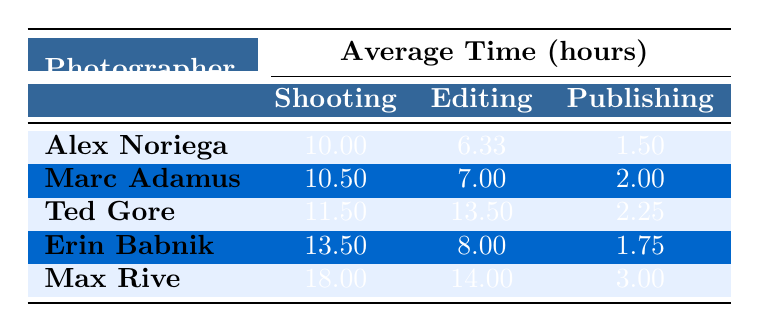What is the average shooting time for Ted Gore? The table shows that Ted Gore has two entries. The shooting times are 9 hours and 14 hours. To find the average, we calculate (9 + 14) / 2 = 23 / 2 = 11.5 hours.
Answer: 11.5 hours Which photographer spent the most time on editing? Looking at the editing times, Ted Gore has the highest time of 13.5 hours. We compare the editing times of all photographers, and Ted Gore's editing time is greater than the others.
Answer: Ted Gore Is the average publishing time for Erin Babnik greater than 2 hours? The table shows that Erin Babnik has an average publishing time of 1.75 hours. Since 1.75 is less than 2, we conclude that her average publishing time is not greater than 2 hours.
Answer: No What is the total time spent on all three phases by Max Rive? Max Rive's times are 18 hours for shooting, 14 hours for editing, and 3 hours for publishing. To find the total, we add these amounts together: 18 + 14 + 3 = 35 hours.
Answer: 35 hours Who spent the least amount of time on publishing? Reviewing the publishing times, the lowest is 1 hour, which belongs to both Yosemite and Oregon Coast entries by Alex Noriega and Marc Adamus. Therefore, these photographers spent the least time on publishing.
Answer: Alex Noriega and Marc Adamus What is the average editing time across all photographers? To calculate the average editing time, we sum all editing times: (8 + 6 + 5 + 10 + 4 + 12 + 15 + 7 + 9 + 14) = 90 hours across 10 photographers. Then, we divide 90 by 10 to get an average of 9 hours.
Answer: 9 hours Did Marc Adamus spend more time on shooting than Erin Babnik? Marc Adamus has an average shooting time of 10.5 hours, while Erin Babnik has 13.5 hours. Since 10.5 is less than 13.5, Marc Adamus did not spend more time on shooting than Erin Babnik.
Answer: No What is the difference in total time spent on shooting between Max Rive and Alex Noriega? Max Rive spent 18 hours and Alex Noriega spent 10 hours on shooting. The difference is calculated as 18 - 10 = 8 hours.
Answer: 8 hours 